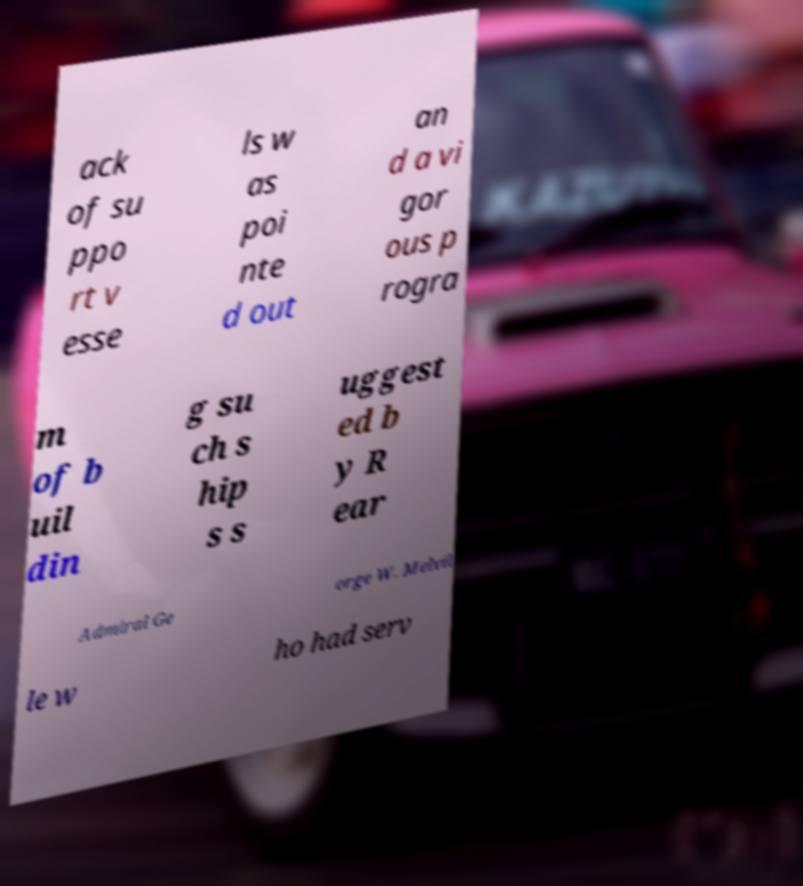Please identify and transcribe the text found in this image. ack of su ppo rt v esse ls w as poi nte d out an d a vi gor ous p rogra m of b uil din g su ch s hip s s uggest ed b y R ear Admiral Ge orge W. Melvil le w ho had serv 